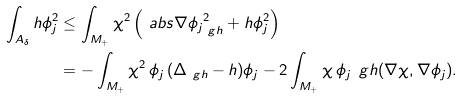<formula> <loc_0><loc_0><loc_500><loc_500>\int _ { A _ { \delta } } h \phi _ { j } ^ { 2 } & \leq \int _ { M _ { + } } \chi ^ { 2 } \left ( \ a b s { \nabla \phi _ { j } } _ { \ g h } ^ { 2 } + h \phi _ { j } ^ { 2 } \right ) \\ & = - \int _ { M _ { + } } \chi ^ { 2 } \, \phi _ { j } \, ( \Delta _ { \ g h } - h ) \phi _ { j } - 2 \int _ { M _ { + } } \chi \, \phi _ { j } \, \ g h ( \nabla \chi , \nabla \phi _ { j } ) .</formula> 